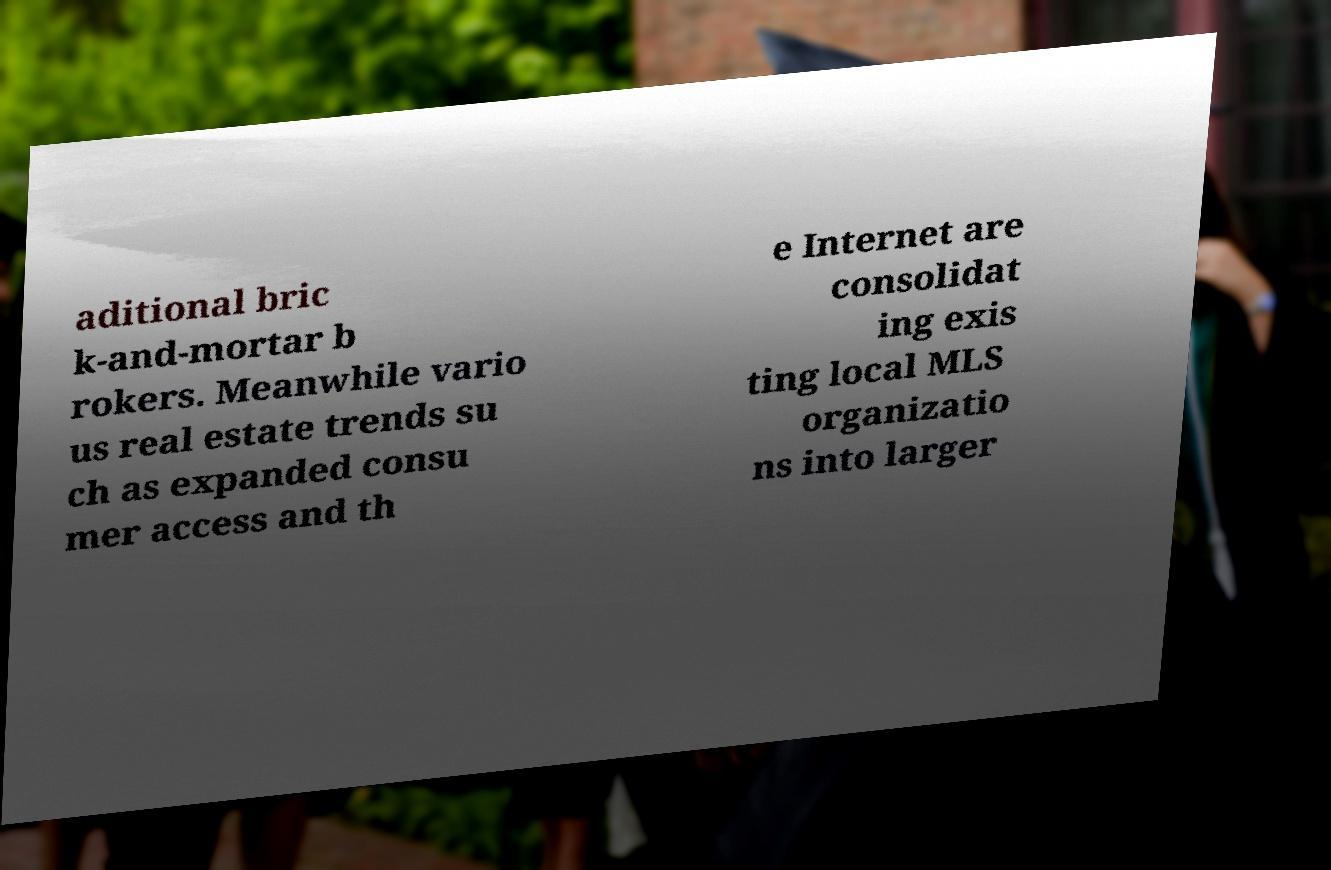I need the written content from this picture converted into text. Can you do that? aditional bric k-and-mortar b rokers. Meanwhile vario us real estate trends su ch as expanded consu mer access and th e Internet are consolidat ing exis ting local MLS organizatio ns into larger 